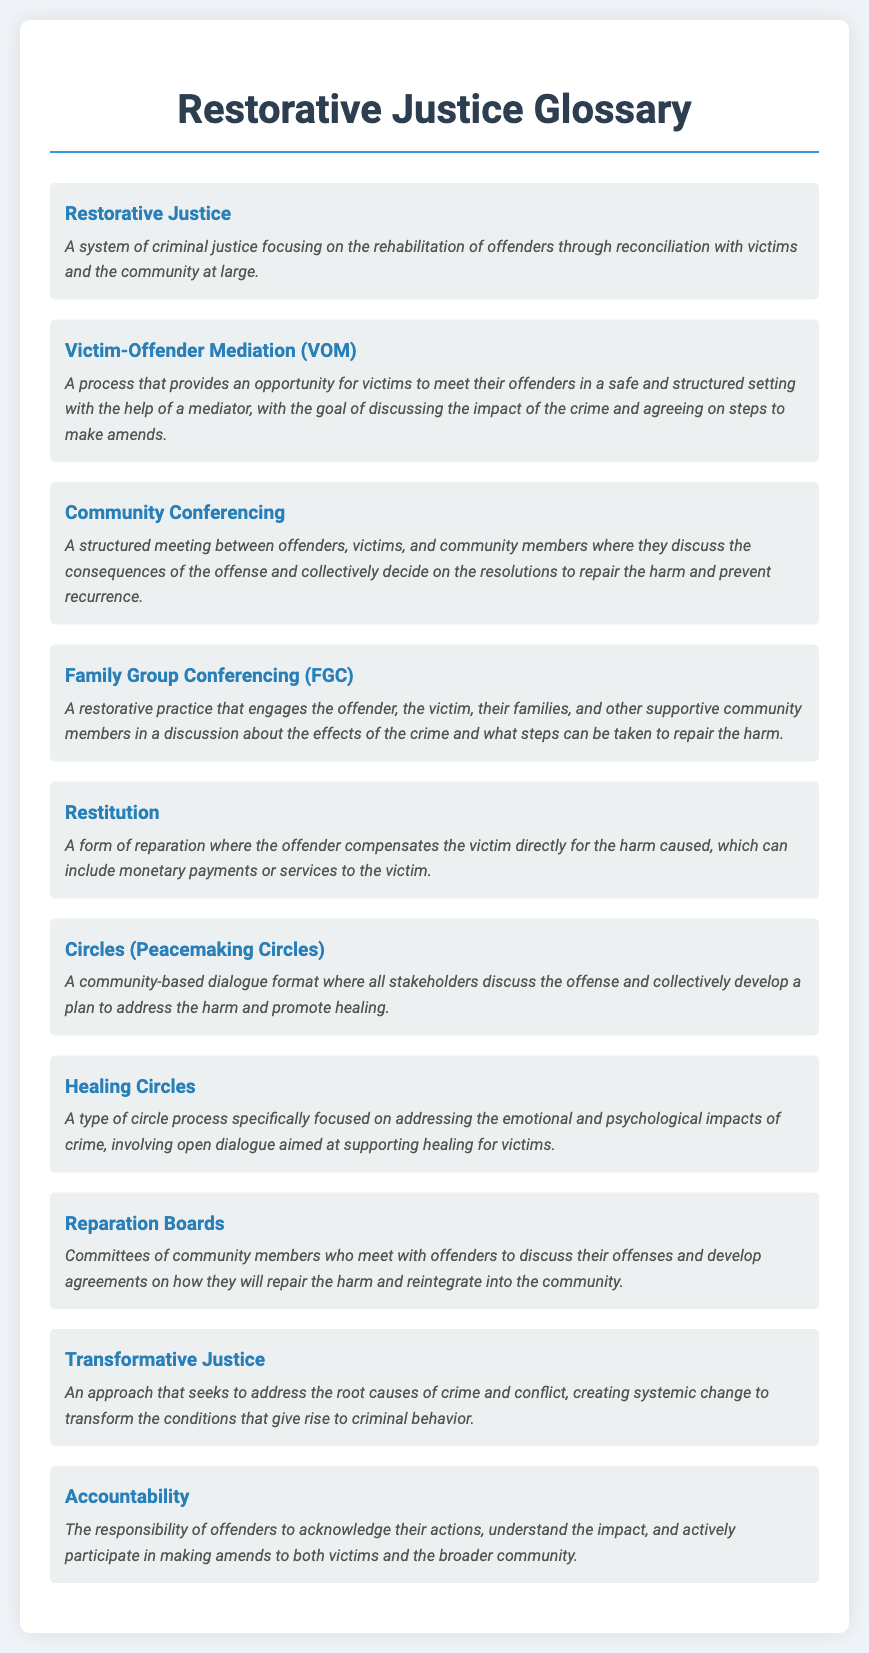What is the term that describes a system focusing on rehabilitation through reconciliation? The term referring to a system of criminal justice focusing on rehabilitation through reconciliation is mentioned in the document.
Answer: Restorative Justice What process allows victims to meet their offenders in a structured setting? The document defines a process where victims meet offenders with a mediator to discuss the impact of the crime.
Answer: Victim-Offender Mediation (VOM) What is the main focus of Community Conferencing? The document specifies that Community Conferencing involves discussing the consequences of an offense and collectively deciding on resolutions to repair harm.
Answer: Collective resolutions How does Restitution aim to repair harm caused by offenders? The document outlines that Restitution involves the offender compensating the victim directly for the harm caused.
Answer: Compensation What is the main purpose of Circles (Peacemaking Circles)? The document mentions that Circles are intended for community-based dialogue to discuss the offense and develop a plan to address harm.
Answer: Community-based dialogue Which restorative practice includes families in the discussion about a crime's effects? The document describes a practice that engages families in discussions about the crime's effects and steps to repair the harm.
Answer: Family Group Conferencing (FGC) What is one outcome that Accountability seeks from offenders? The document states that Accountability requires offenders to acknowledge their actions and participate in making amends.
Answer: Acknowledge actions What type of justice addresses the root causes of crime? The document specifically lists an approach that aims to address the underlying issues leading to criminal behavior.
Answer: Transformative Justice 